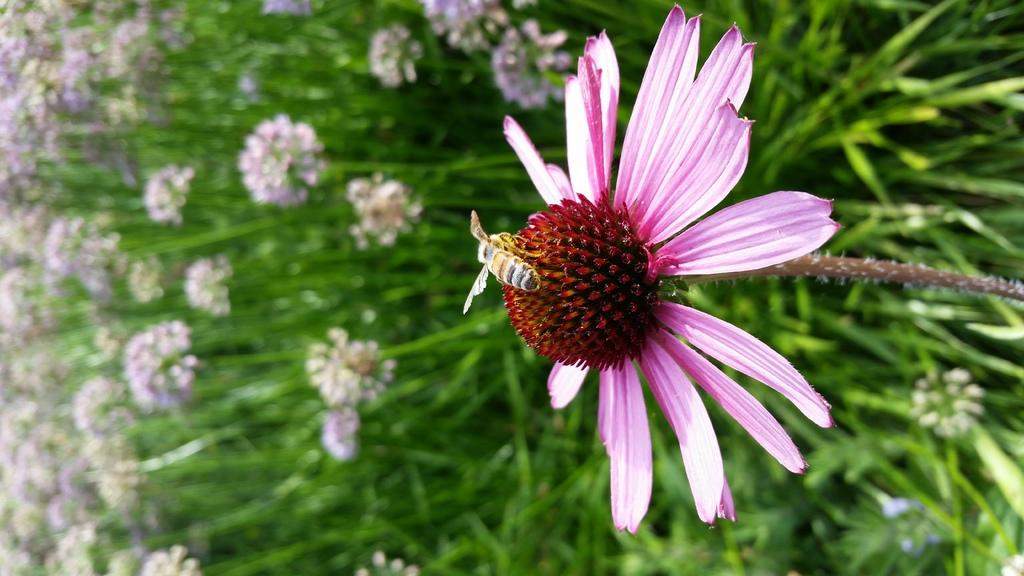What is on the flower in the image? There is an insect on a flower in the image. What can be seen in the background of the image? There are plants with flowers and leaves in the background of the image. What type of furniture is visible in the image? There is no furniture present in the image; it features an insect on a flower and plants in the background. 